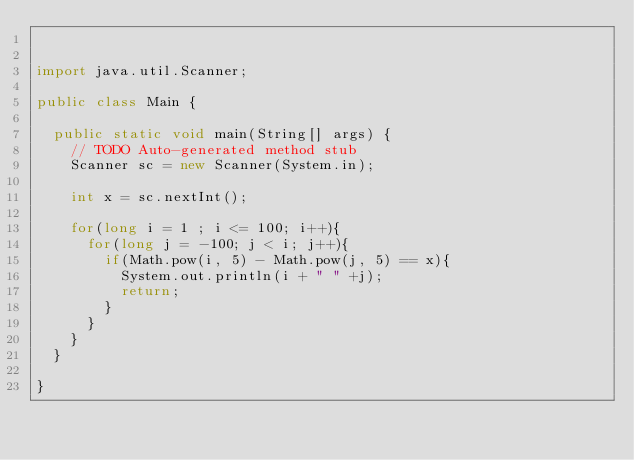Convert code to text. <code><loc_0><loc_0><loc_500><loc_500><_Java_>

import java.util.Scanner;

public class Main {

	public static void main(String[] args) {
		// TODO Auto-generated method stub
		Scanner sc = new Scanner(System.in);

		int x = sc.nextInt();

		for(long i = 1 ; i <= 100; i++){
			for(long j = -100; j < i; j++){
				if(Math.pow(i, 5) - Math.pow(j, 5) == x){
					System.out.println(i + " " +j);
					return;
				}
			}
		}
	}

}
</code> 